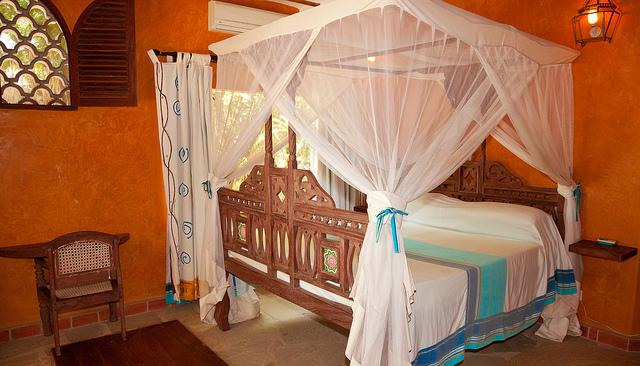The walls are most likely covered in what material?

Choices:
A) slate
B) plaster
C) wood
D) canvas plaster 